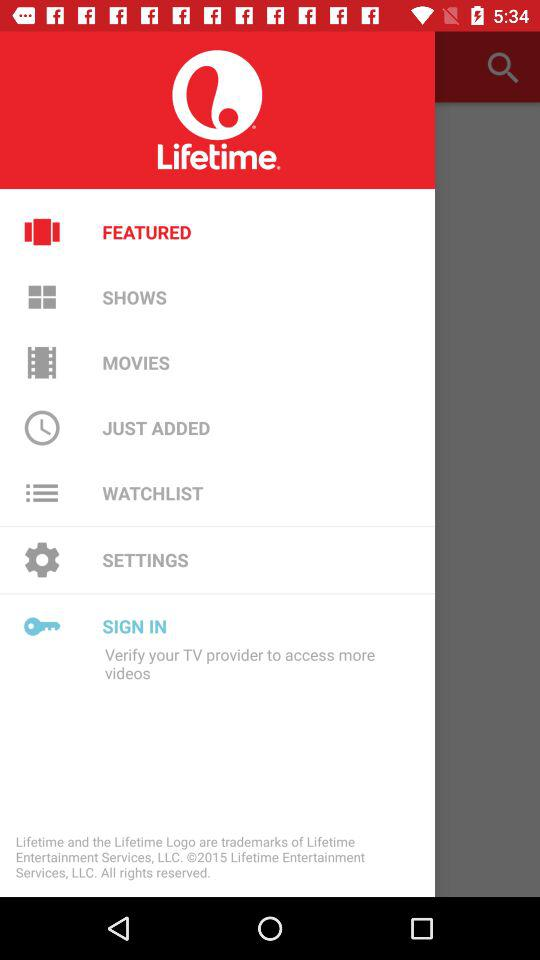Which item is selected? The selected items are "FEATURED" and "SIGN IN". 